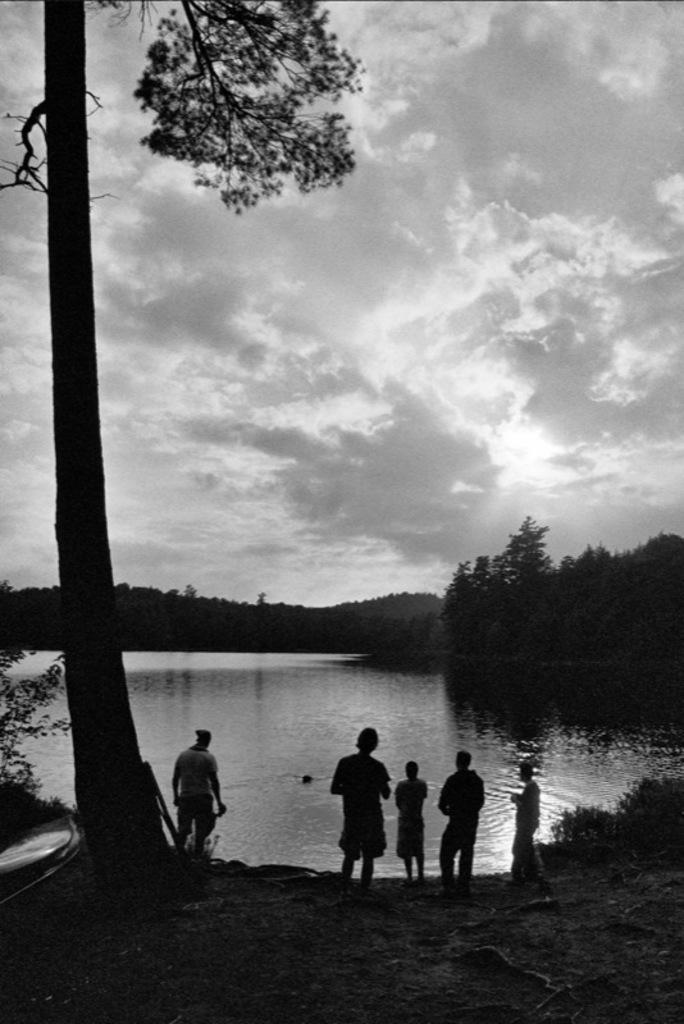Can you describe this image briefly? This is a black and white picture where we can see these people are standing on the ground. On the left side of the image, we can see a tree. In the background, I can see water, trees, hills and the cloudy Sky. 